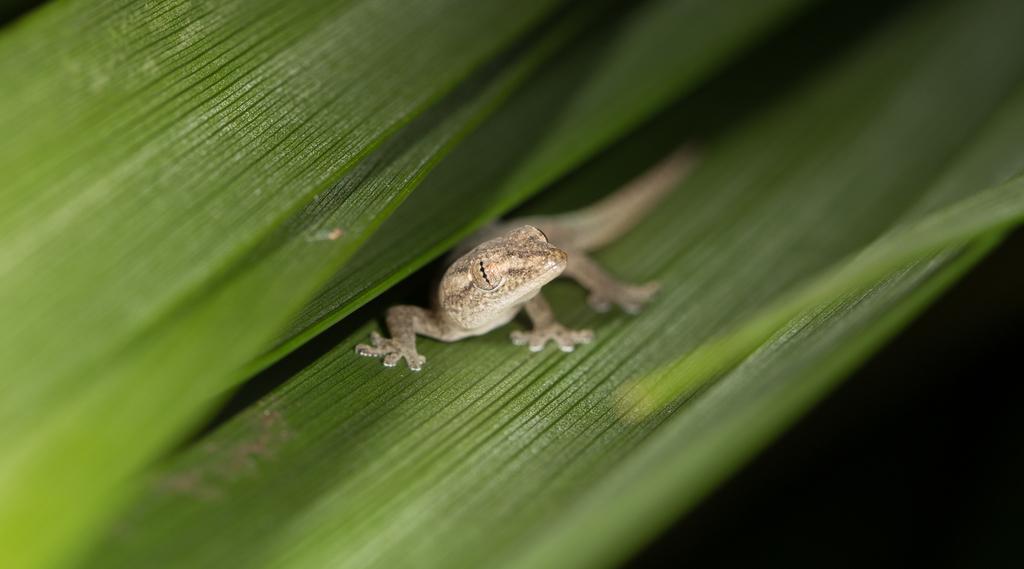Describe this image in one or two sentences. In this picture it looks like a reptile on a green leaf. 